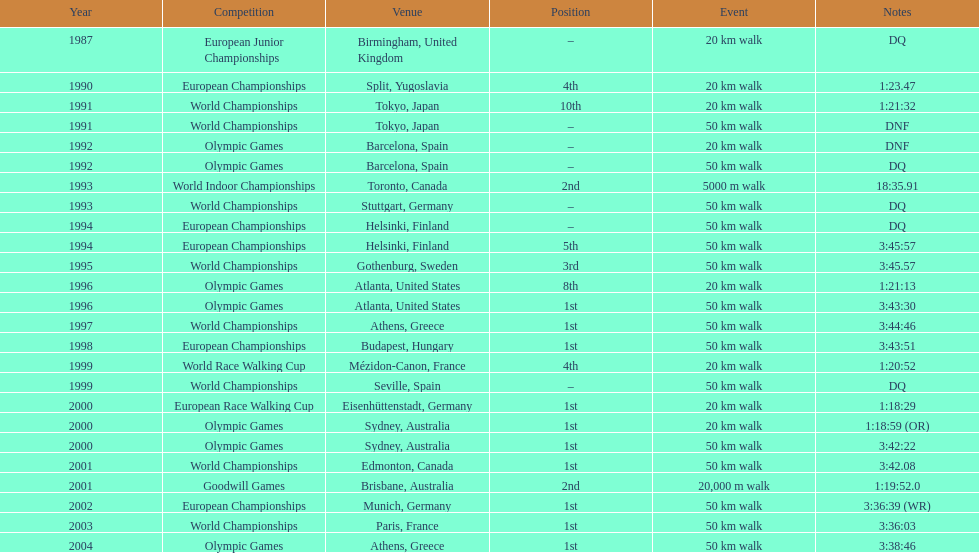Which of the competitions were 50 km walks? World Championships, Olympic Games, World Championships, European Championships, European Championships, World Championships, Olympic Games, World Championships, European Championships, World Championships, Olympic Games, World Championships, European Championships, World Championships, Olympic Games. Of these, which took place during or after the year 2000? Olympic Games, World Championships, European Championships, World Championships, Olympic Games. From these, which took place in athens, greece? Olympic Games. What was the time to finish for this competition? 3:38:46. 